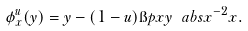Convert formula to latex. <formula><loc_0><loc_0><loc_500><loc_500>\phi _ { x } ^ { u } ( y ) = y - ( 1 - u ) \i p { x } { y } \ a b s { x } ^ { - 2 } x .</formula> 